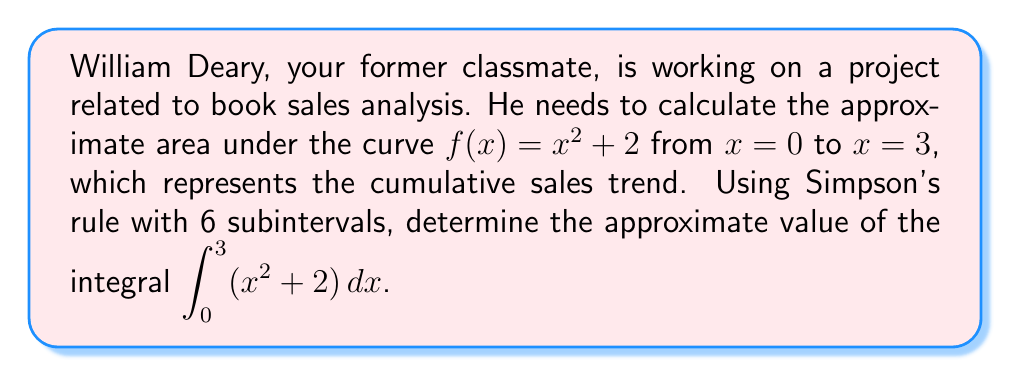Could you help me with this problem? Let's apply Simpson's rule to approximate the integral:

1) Simpson's rule formula:
   $$\int_a^b f(x) dx \approx \frac{h}{3}[f(x_0) + 4f(x_1) + 2f(x_2) + 4f(x_3) + 2f(x_4) + 4f(x_5) + f(x_6)]$$
   where $h = \frac{b-a}{n}$, and $n$ is the number of subintervals (6 in this case).

2) Calculate $h$:
   $h = \frac{3-0}{6} = 0.5$

3) Calculate $x_i$ values:
   $x_0 = 0$, $x_1 = 0.5$, $x_2 = 1$, $x_3 = 1.5$, $x_4 = 2$, $x_5 = 2.5$, $x_6 = 3$

4) Calculate $f(x_i)$ values:
   $f(x_0) = 0^2 + 2 = 2$
   $f(x_1) = 0.5^2 + 2 = 2.25$
   $f(x_2) = 1^2 + 2 = 3$
   $f(x_3) = 1.5^2 + 2 = 4.25$
   $f(x_4) = 2^2 + 2 = 6$
   $f(x_5) = 2.5^2 + 2 = 8.25$
   $f(x_6) = 3^2 + 2 = 11$

5) Apply Simpson's rule:
   $$\frac{0.5}{3}[2 + 4(2.25) + 2(3) + 4(4.25) + 2(6) + 4(8.25) + 11]$$
   $$= \frac{0.5}{3}[2 + 9 + 6 + 17 + 12 + 33 + 11]$$
   $$= \frac{0.5}{3}[90]$$
   $$= 15$$

Thus, the approximate value of the integral is 15.
Answer: 15 